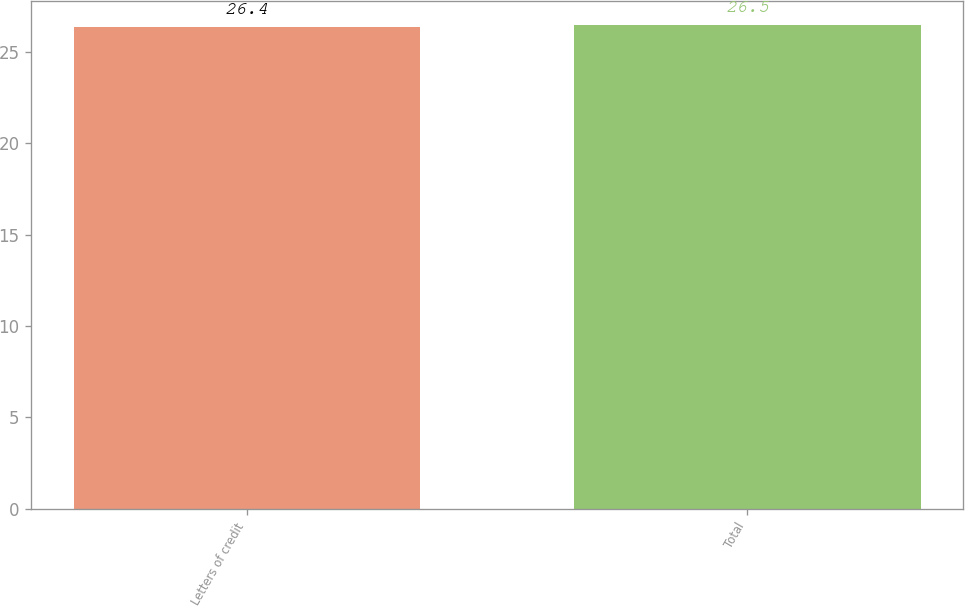<chart> <loc_0><loc_0><loc_500><loc_500><bar_chart><fcel>Letters of credit<fcel>Total<nl><fcel>26.4<fcel>26.5<nl></chart> 